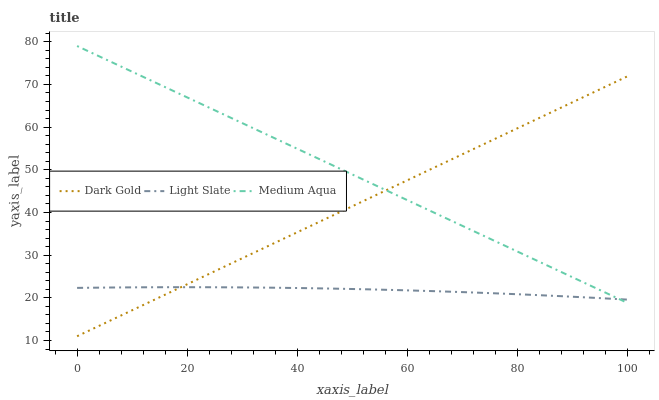Does Dark Gold have the minimum area under the curve?
Answer yes or no. No. Does Dark Gold have the maximum area under the curve?
Answer yes or no. No. Is Medium Aqua the smoothest?
Answer yes or no. No. Is Medium Aqua the roughest?
Answer yes or no. No. Does Medium Aqua have the lowest value?
Answer yes or no. No. Does Dark Gold have the highest value?
Answer yes or no. No. 